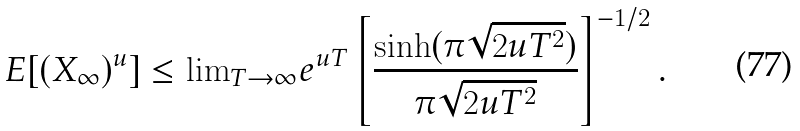Convert formula to latex. <formula><loc_0><loc_0><loc_500><loc_500>E [ ( X _ { \infty } ) ^ { u } ] & \leq { \lim } _ { T \to \infty } e ^ { u T } \left [ \frac { \sinh ( \pi \sqrt { 2 u T ^ { 2 } } ) } { \pi \sqrt { 2 u T ^ { 2 } } } \right ] ^ { - 1 / 2 } .</formula> 